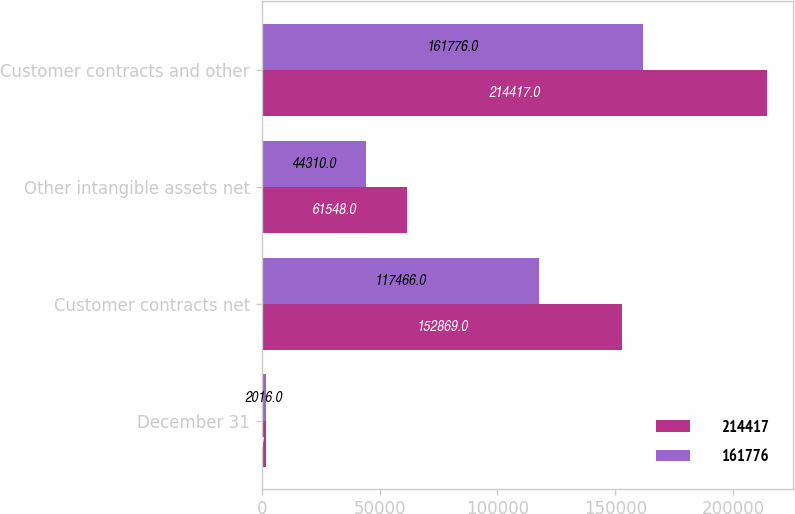Convert chart to OTSL. <chart><loc_0><loc_0><loc_500><loc_500><stacked_bar_chart><ecel><fcel>December 31<fcel>Customer contracts net<fcel>Other intangible assets net<fcel>Customer contracts and other<nl><fcel>214417<fcel>2017<fcel>152869<fcel>61548<fcel>214417<nl><fcel>161776<fcel>2016<fcel>117466<fcel>44310<fcel>161776<nl></chart> 